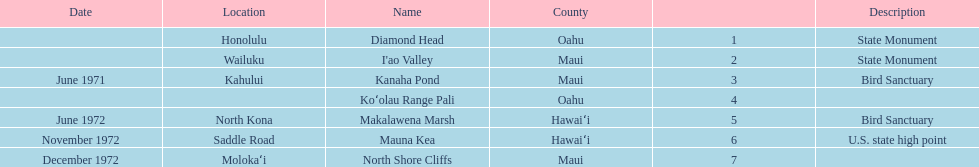How many names lack a description? 2. 